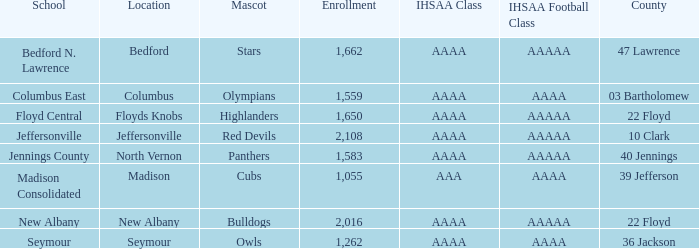What is bedford's mascot? Stars. 